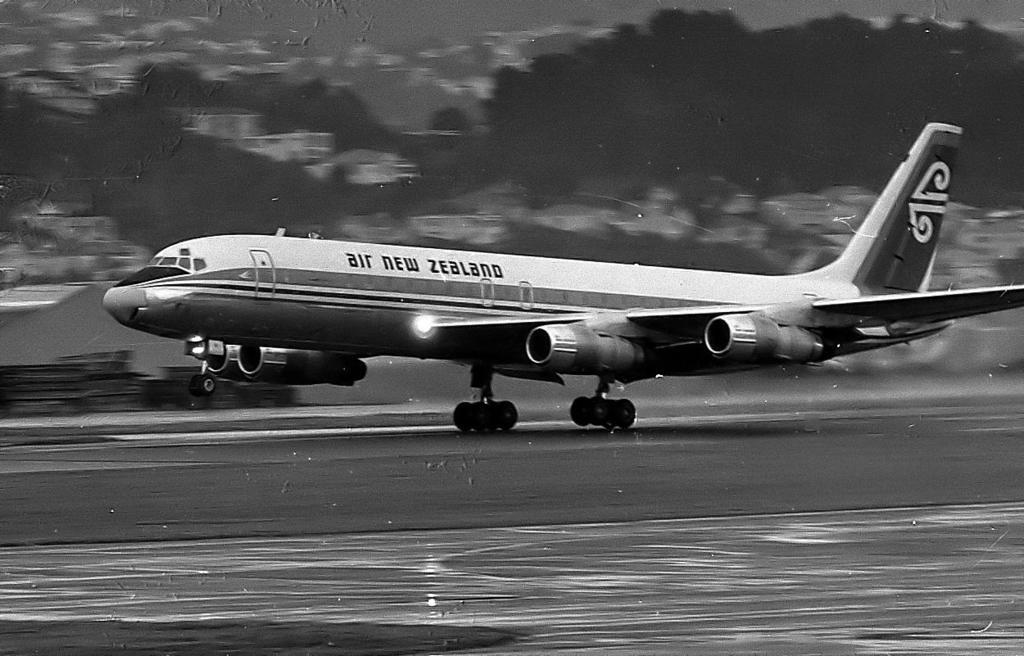<image>
Relay a brief, clear account of the picture shown. A jet airplane operated by Air New Zealand. 